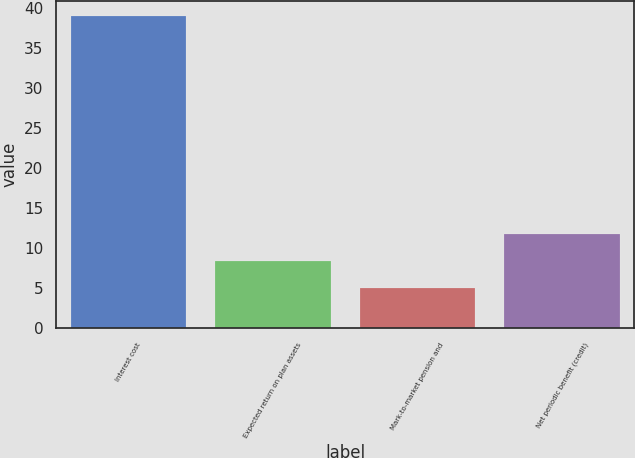<chart> <loc_0><loc_0><loc_500><loc_500><bar_chart><fcel>Interest cost<fcel>Expected return on plan assets<fcel>Mark-to-market pension and<fcel>Net periodic benefit (credit)<nl><fcel>39<fcel>8.4<fcel>5<fcel>11.8<nl></chart> 